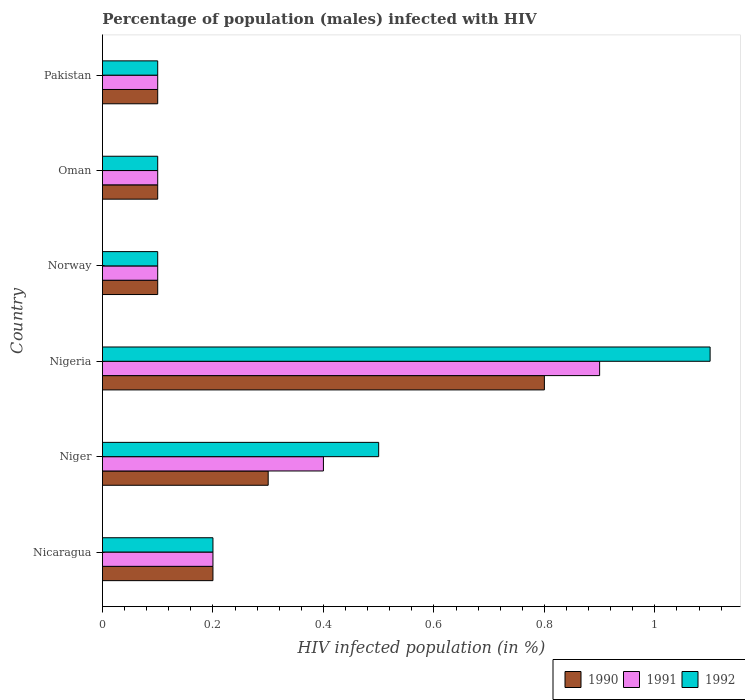How many different coloured bars are there?
Your answer should be very brief. 3. How many groups of bars are there?
Offer a very short reply. 6. How many bars are there on the 6th tick from the bottom?
Offer a very short reply. 3. What is the label of the 5th group of bars from the top?
Keep it short and to the point. Niger. In how many cases, is the number of bars for a given country not equal to the number of legend labels?
Provide a short and direct response. 0. Across all countries, what is the maximum percentage of HIV infected male population in 1992?
Make the answer very short. 1.1. In which country was the percentage of HIV infected male population in 1990 maximum?
Ensure brevity in your answer.  Nigeria. What is the total percentage of HIV infected male population in 1991 in the graph?
Your response must be concise. 1.8. What is the difference between the percentage of HIV infected male population in 1992 in Nicaragua and that in Nigeria?
Your response must be concise. -0.9. What is the difference between the percentage of HIV infected male population in 1991 in Pakistan and the percentage of HIV infected male population in 1990 in Niger?
Keep it short and to the point. -0.2. What is the average percentage of HIV infected male population in 1991 per country?
Your response must be concise. 0.3. What is the ratio of the percentage of HIV infected male population in 1991 in Nicaragua to that in Oman?
Offer a terse response. 2. What is the difference between the highest and the second highest percentage of HIV infected male population in 1992?
Ensure brevity in your answer.  0.6. What is the difference between the highest and the lowest percentage of HIV infected male population in 1991?
Provide a succinct answer. 0.8. What does the 1st bar from the top in Niger represents?
Provide a succinct answer. 1992. What does the 3rd bar from the bottom in Oman represents?
Your response must be concise. 1992. Is it the case that in every country, the sum of the percentage of HIV infected male population in 1992 and percentage of HIV infected male population in 1991 is greater than the percentage of HIV infected male population in 1990?
Give a very brief answer. Yes. How many bars are there?
Give a very brief answer. 18. Are all the bars in the graph horizontal?
Your answer should be compact. Yes. How many countries are there in the graph?
Keep it short and to the point. 6. What is the difference between two consecutive major ticks on the X-axis?
Your answer should be very brief. 0.2. Are the values on the major ticks of X-axis written in scientific E-notation?
Give a very brief answer. No. Does the graph contain grids?
Offer a terse response. No. How many legend labels are there?
Provide a succinct answer. 3. How are the legend labels stacked?
Give a very brief answer. Horizontal. What is the title of the graph?
Your response must be concise. Percentage of population (males) infected with HIV. What is the label or title of the X-axis?
Provide a succinct answer. HIV infected population (in %). What is the HIV infected population (in %) of 1990 in Nicaragua?
Offer a very short reply. 0.2. What is the HIV infected population (in %) of 1992 in Nicaragua?
Give a very brief answer. 0.2. What is the HIV infected population (in %) in 1992 in Niger?
Ensure brevity in your answer.  0.5. What is the HIV infected population (in %) of 1990 in Nigeria?
Offer a terse response. 0.8. What is the HIV infected population (in %) in 1991 in Nigeria?
Your answer should be very brief. 0.9. What is the HIV infected population (in %) in 1992 in Nigeria?
Make the answer very short. 1.1. What is the HIV infected population (in %) in 1990 in Norway?
Give a very brief answer. 0.1. What is the HIV infected population (in %) in 1991 in Norway?
Your answer should be compact. 0.1. What is the HIV infected population (in %) of 1991 in Oman?
Offer a very short reply. 0.1. What is the HIV infected population (in %) of 1992 in Oman?
Your response must be concise. 0.1. What is the HIV infected population (in %) of 1990 in Pakistan?
Provide a short and direct response. 0.1. What is the HIV infected population (in %) of 1992 in Pakistan?
Your answer should be compact. 0.1. Across all countries, what is the maximum HIV infected population (in %) in 1990?
Your answer should be compact. 0.8. Across all countries, what is the minimum HIV infected population (in %) in 1990?
Your answer should be compact. 0.1. Across all countries, what is the minimum HIV infected population (in %) in 1992?
Provide a short and direct response. 0.1. What is the total HIV infected population (in %) in 1990 in the graph?
Make the answer very short. 1.6. What is the total HIV infected population (in %) in 1991 in the graph?
Provide a short and direct response. 1.8. What is the difference between the HIV infected population (in %) of 1992 in Nicaragua and that in Nigeria?
Offer a terse response. -0.9. What is the difference between the HIV infected population (in %) in 1990 in Nicaragua and that in Oman?
Offer a terse response. 0.1. What is the difference between the HIV infected population (in %) of 1991 in Nicaragua and that in Pakistan?
Offer a terse response. 0.1. What is the difference between the HIV infected population (in %) of 1991 in Niger and that in Nigeria?
Provide a succinct answer. -0.5. What is the difference between the HIV infected population (in %) of 1992 in Niger and that in Norway?
Ensure brevity in your answer.  0.4. What is the difference between the HIV infected population (in %) of 1992 in Niger and that in Oman?
Your response must be concise. 0.4. What is the difference between the HIV infected population (in %) in 1991 in Niger and that in Pakistan?
Offer a terse response. 0.3. What is the difference between the HIV infected population (in %) of 1992 in Niger and that in Pakistan?
Give a very brief answer. 0.4. What is the difference between the HIV infected population (in %) in 1991 in Nigeria and that in Norway?
Make the answer very short. 0.8. What is the difference between the HIV infected population (in %) in 1990 in Nigeria and that in Oman?
Offer a terse response. 0.7. What is the difference between the HIV infected population (in %) in 1991 in Nigeria and that in Oman?
Make the answer very short. 0.8. What is the difference between the HIV infected population (in %) of 1992 in Nigeria and that in Oman?
Your response must be concise. 1. What is the difference between the HIV infected population (in %) of 1990 in Nigeria and that in Pakistan?
Keep it short and to the point. 0.7. What is the difference between the HIV infected population (in %) of 1991 in Nigeria and that in Pakistan?
Offer a very short reply. 0.8. What is the difference between the HIV infected population (in %) in 1990 in Norway and that in Oman?
Your answer should be compact. 0. What is the difference between the HIV infected population (in %) of 1991 in Norway and that in Oman?
Provide a short and direct response. 0. What is the difference between the HIV infected population (in %) of 1992 in Norway and that in Oman?
Offer a terse response. 0. What is the difference between the HIV infected population (in %) in 1991 in Norway and that in Pakistan?
Your response must be concise. 0. What is the difference between the HIV infected population (in %) in 1992 in Oman and that in Pakistan?
Make the answer very short. 0. What is the difference between the HIV infected population (in %) of 1990 in Nicaragua and the HIV infected population (in %) of 1991 in Niger?
Your answer should be very brief. -0.2. What is the difference between the HIV infected population (in %) of 1990 in Nicaragua and the HIV infected population (in %) of 1992 in Niger?
Your response must be concise. -0.3. What is the difference between the HIV infected population (in %) of 1990 in Nicaragua and the HIV infected population (in %) of 1991 in Nigeria?
Your answer should be very brief. -0.7. What is the difference between the HIV infected population (in %) of 1990 in Nicaragua and the HIV infected population (in %) of 1992 in Nigeria?
Offer a terse response. -0.9. What is the difference between the HIV infected population (in %) in 1990 in Nicaragua and the HIV infected population (in %) in 1991 in Norway?
Provide a succinct answer. 0.1. What is the difference between the HIV infected population (in %) of 1991 in Nicaragua and the HIV infected population (in %) of 1992 in Norway?
Ensure brevity in your answer.  0.1. What is the difference between the HIV infected population (in %) of 1990 in Nicaragua and the HIV infected population (in %) of 1991 in Pakistan?
Offer a terse response. 0.1. What is the difference between the HIV infected population (in %) of 1990 in Nicaragua and the HIV infected population (in %) of 1992 in Pakistan?
Offer a very short reply. 0.1. What is the difference between the HIV infected population (in %) of 1990 in Niger and the HIV infected population (in %) of 1992 in Nigeria?
Offer a very short reply. -0.8. What is the difference between the HIV infected population (in %) of 1991 in Niger and the HIV infected population (in %) of 1992 in Norway?
Offer a terse response. 0.3. What is the difference between the HIV infected population (in %) of 1990 in Niger and the HIV infected population (in %) of 1992 in Oman?
Provide a succinct answer. 0.2. What is the difference between the HIV infected population (in %) in 1990 in Niger and the HIV infected population (in %) in 1991 in Pakistan?
Your answer should be very brief. 0.2. What is the difference between the HIV infected population (in %) of 1990 in Niger and the HIV infected population (in %) of 1992 in Pakistan?
Your answer should be compact. 0.2. What is the difference between the HIV infected population (in %) of 1991 in Niger and the HIV infected population (in %) of 1992 in Pakistan?
Give a very brief answer. 0.3. What is the difference between the HIV infected population (in %) of 1990 in Nigeria and the HIV infected population (in %) of 1991 in Norway?
Offer a very short reply. 0.7. What is the difference between the HIV infected population (in %) of 1990 in Nigeria and the HIV infected population (in %) of 1992 in Norway?
Your response must be concise. 0.7. What is the difference between the HIV infected population (in %) in 1991 in Nigeria and the HIV infected population (in %) in 1992 in Norway?
Give a very brief answer. 0.8. What is the difference between the HIV infected population (in %) of 1990 in Nigeria and the HIV infected population (in %) of 1991 in Oman?
Offer a terse response. 0.7. What is the difference between the HIV infected population (in %) of 1990 in Nigeria and the HIV infected population (in %) of 1992 in Pakistan?
Your response must be concise. 0.7. What is the difference between the HIV infected population (in %) in 1991 in Nigeria and the HIV infected population (in %) in 1992 in Pakistan?
Provide a short and direct response. 0.8. What is the difference between the HIV infected population (in %) of 1991 in Norway and the HIV infected population (in %) of 1992 in Oman?
Your answer should be very brief. 0. What is the difference between the HIV infected population (in %) of 1991 in Norway and the HIV infected population (in %) of 1992 in Pakistan?
Your answer should be very brief. 0. What is the difference between the HIV infected population (in %) in 1990 in Oman and the HIV infected population (in %) in 1991 in Pakistan?
Offer a terse response. 0. What is the average HIV infected population (in %) of 1990 per country?
Your answer should be compact. 0.27. What is the difference between the HIV infected population (in %) in 1990 and HIV infected population (in %) in 1991 in Nicaragua?
Provide a succinct answer. 0. What is the difference between the HIV infected population (in %) of 1991 and HIV infected population (in %) of 1992 in Nigeria?
Offer a terse response. -0.2. What is the difference between the HIV infected population (in %) of 1990 and HIV infected population (in %) of 1992 in Norway?
Offer a very short reply. 0. What is the difference between the HIV infected population (in %) of 1991 and HIV infected population (in %) of 1992 in Oman?
Offer a terse response. 0. What is the difference between the HIV infected population (in %) in 1990 and HIV infected population (in %) in 1992 in Pakistan?
Offer a terse response. 0. What is the ratio of the HIV infected population (in %) of 1990 in Nicaragua to that in Niger?
Give a very brief answer. 0.67. What is the ratio of the HIV infected population (in %) of 1991 in Nicaragua to that in Niger?
Make the answer very short. 0.5. What is the ratio of the HIV infected population (in %) of 1992 in Nicaragua to that in Niger?
Ensure brevity in your answer.  0.4. What is the ratio of the HIV infected population (in %) of 1991 in Nicaragua to that in Nigeria?
Offer a very short reply. 0.22. What is the ratio of the HIV infected population (in %) in 1992 in Nicaragua to that in Nigeria?
Ensure brevity in your answer.  0.18. What is the ratio of the HIV infected population (in %) in 1990 in Nicaragua to that in Oman?
Your response must be concise. 2. What is the ratio of the HIV infected population (in %) in 1991 in Nicaragua to that in Oman?
Give a very brief answer. 2. What is the ratio of the HIV infected population (in %) in 1992 in Nicaragua to that in Oman?
Make the answer very short. 2. What is the ratio of the HIV infected population (in %) of 1992 in Nicaragua to that in Pakistan?
Offer a very short reply. 2. What is the ratio of the HIV infected population (in %) in 1990 in Niger to that in Nigeria?
Offer a terse response. 0.38. What is the ratio of the HIV infected population (in %) of 1991 in Niger to that in Nigeria?
Your answer should be very brief. 0.44. What is the ratio of the HIV infected population (in %) of 1992 in Niger to that in Nigeria?
Your response must be concise. 0.45. What is the ratio of the HIV infected population (in %) of 1990 in Niger to that in Norway?
Provide a succinct answer. 3. What is the ratio of the HIV infected population (in %) of 1990 in Niger to that in Oman?
Ensure brevity in your answer.  3. What is the ratio of the HIV infected population (in %) in 1991 in Niger to that in Oman?
Provide a short and direct response. 4. What is the ratio of the HIV infected population (in %) in 1992 in Niger to that in Oman?
Your answer should be compact. 5. What is the ratio of the HIV infected population (in %) in 1991 in Niger to that in Pakistan?
Make the answer very short. 4. What is the ratio of the HIV infected population (in %) in 1992 in Niger to that in Pakistan?
Make the answer very short. 5. What is the ratio of the HIV infected population (in %) of 1992 in Nigeria to that in Norway?
Offer a terse response. 11. What is the ratio of the HIV infected population (in %) of 1992 in Nigeria to that in Oman?
Make the answer very short. 11. What is the ratio of the HIV infected population (in %) in 1990 in Nigeria to that in Pakistan?
Offer a very short reply. 8. What is the ratio of the HIV infected population (in %) in 1992 in Nigeria to that in Pakistan?
Offer a terse response. 11. What is the ratio of the HIV infected population (in %) of 1991 in Norway to that in Oman?
Offer a very short reply. 1. What is the ratio of the HIV infected population (in %) of 1991 in Norway to that in Pakistan?
Your answer should be compact. 1. What is the ratio of the HIV infected population (in %) of 1990 in Oman to that in Pakistan?
Offer a very short reply. 1. What is the ratio of the HIV infected population (in %) in 1991 in Oman to that in Pakistan?
Offer a very short reply. 1. What is the ratio of the HIV infected population (in %) in 1992 in Oman to that in Pakistan?
Your response must be concise. 1. What is the difference between the highest and the lowest HIV infected population (in %) in 1990?
Offer a terse response. 0.7. 